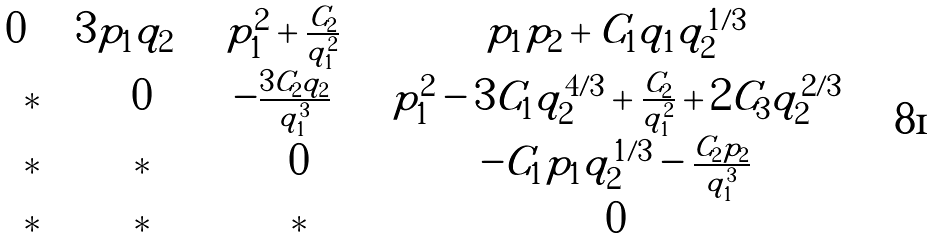<formula> <loc_0><loc_0><loc_500><loc_500>\begin{matrix} 0 \quad & 3 p _ { 1 } q _ { 2 } \quad & p _ { 1 } ^ { 2 } + \frac { C _ { 2 } } { q _ { 1 } ^ { 2 } } \quad & p _ { 1 } p _ { 2 } + C _ { 1 } q _ { 1 } q _ { 2 } ^ { 1 / 3 } \\ * & 0 & - \frac { 3 C _ { 2 } q _ { 2 } } { q _ { 1 } ^ { 3 } } \quad & p _ { 1 } ^ { 2 } - 3 C _ { 1 } q _ { 2 } ^ { 4 / 3 } + \frac { C _ { 2 } } { q _ { 1 } ^ { 2 } } + 2 C _ { 3 } q _ { 2 } ^ { 2 / 3 } \\ * & * & 0 & - C _ { 1 } p _ { 1 } q _ { 2 } ^ { 1 / 3 } - \frac { C _ { 2 } p _ { 2 } } { q _ { 1 } ^ { 3 } } \\ * & * & * & 0 \end{matrix}</formula> 